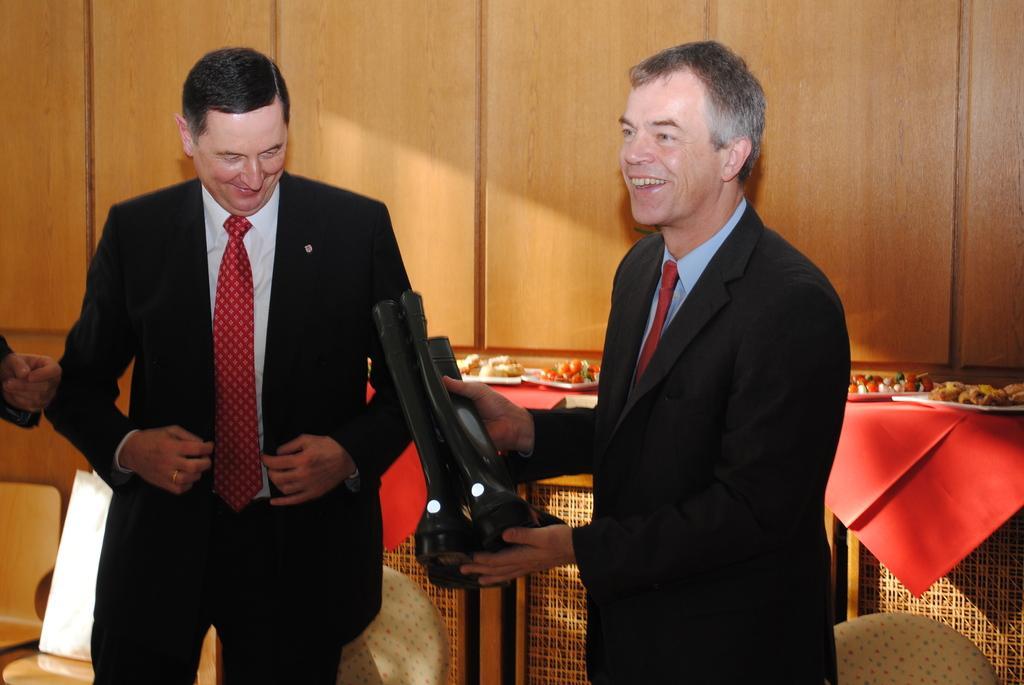In one or two sentences, can you explain what this image depicts? In this picture we can see there are two people standing and a man is holding a pair of boots. Behind the people there are some food items and a wooden wall. 